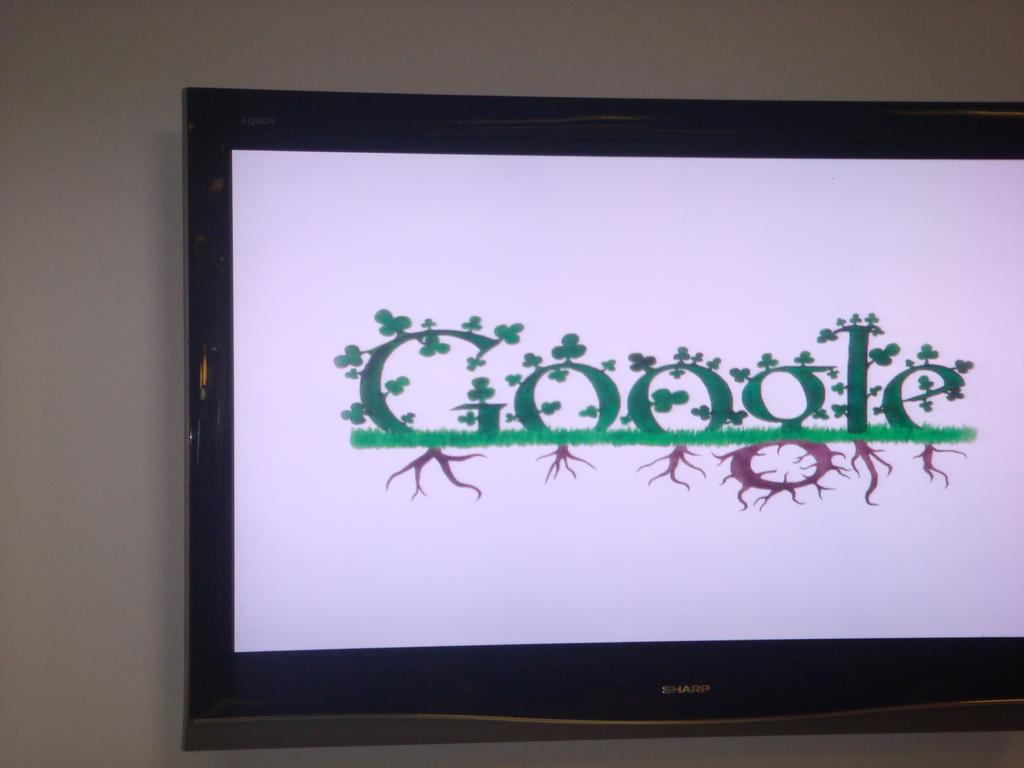<image>
Describe the image concisely. A monitor shows the Google logo which shamrocks on the work and roots below it. 